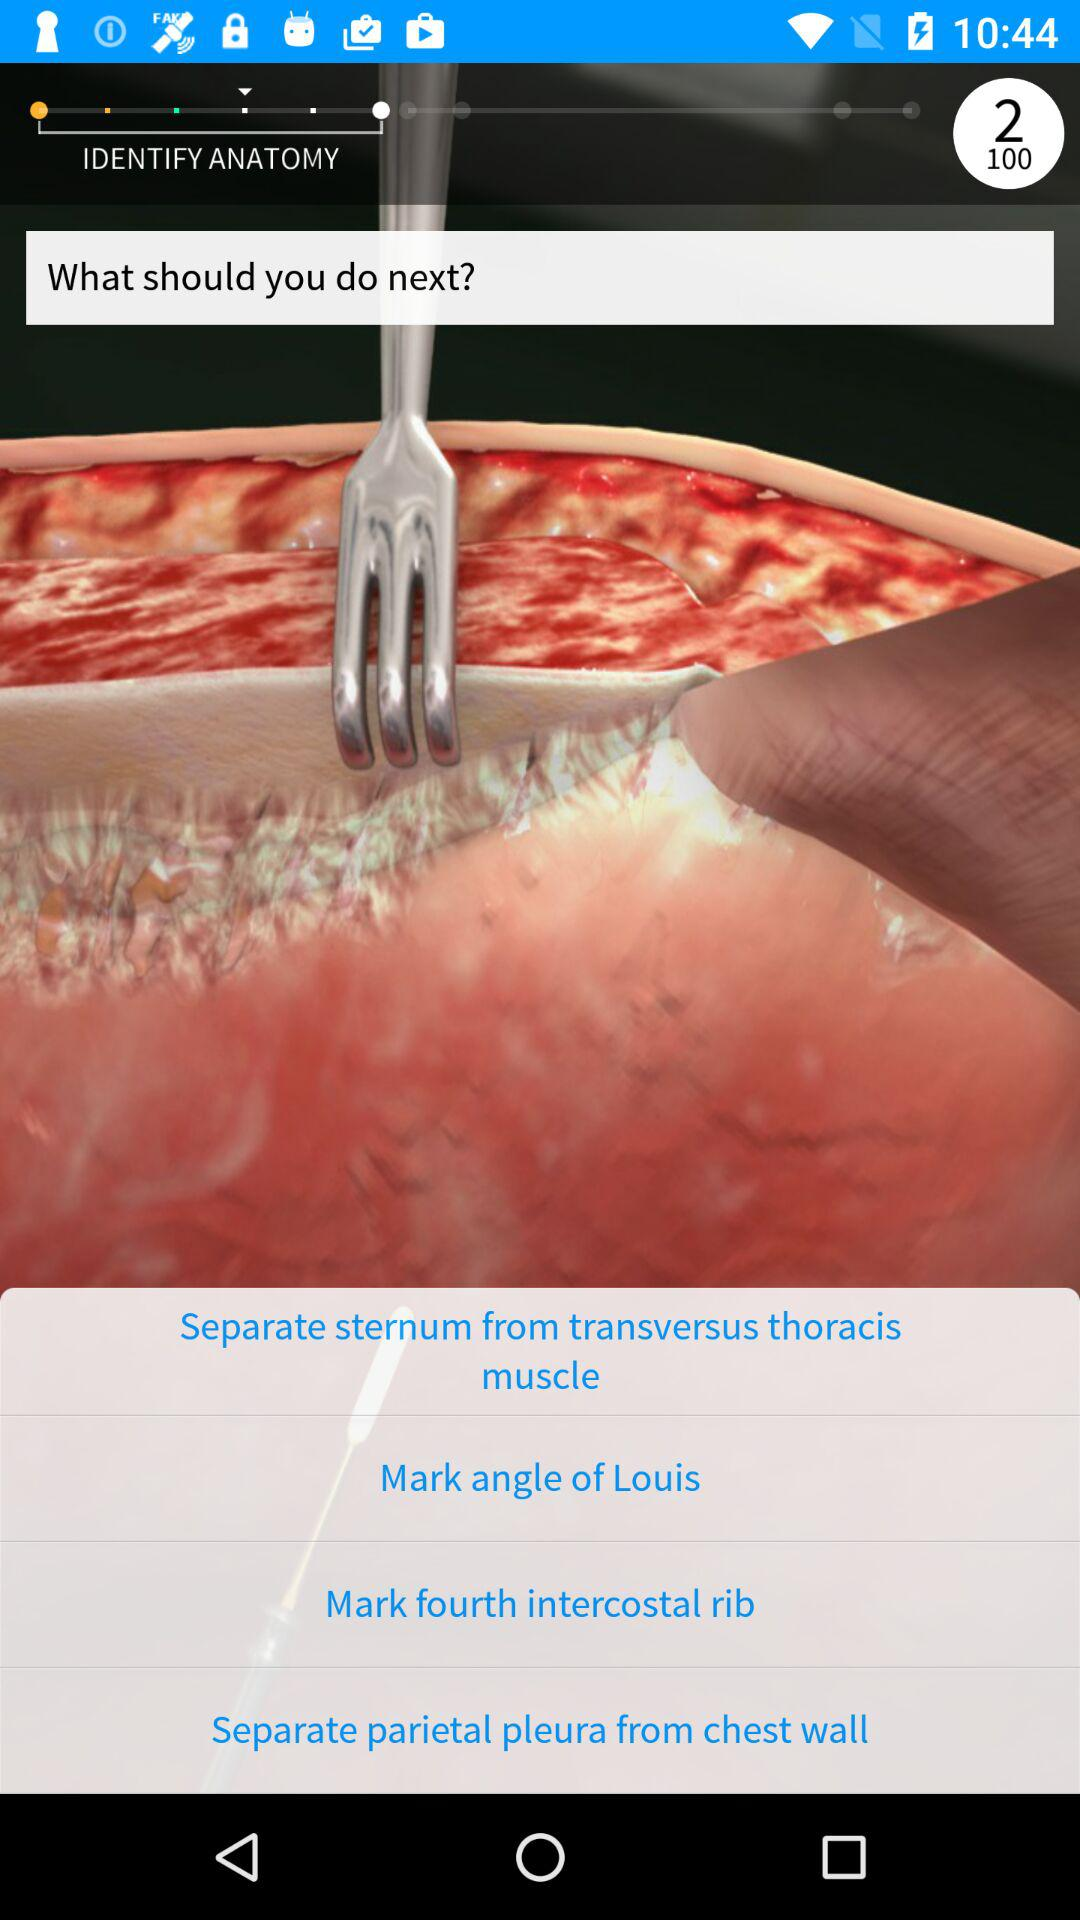How many steps are there in the surgical procedure?
Answer the question using a single word or phrase. 4 